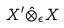<formula> <loc_0><loc_0><loc_500><loc_500>X ^ { \prime } \hat { \otimes } _ { \epsilon } X</formula> 